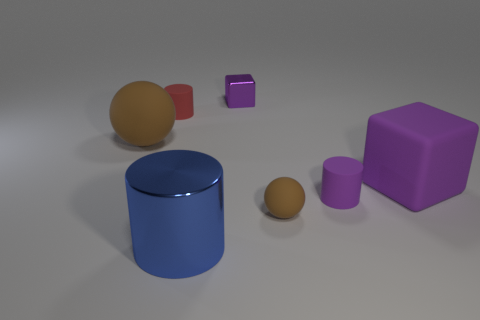There is a brown matte sphere that is left of the shiny cube; is its size the same as the purple object behind the tiny red rubber thing?
Offer a terse response. No. What number of balls are either tiny brown matte objects or big purple matte things?
Keep it short and to the point. 1. Are any tiny yellow shiny balls visible?
Provide a succinct answer. No. Does the large ball have the same color as the small ball?
Make the answer very short. Yes. How many objects are either cylinders that are on the left side of the tiny metallic object or large blue metal cylinders?
Offer a very short reply. 2. There is a tiny purple thing that is behind the purple cylinder that is on the right side of the big blue shiny object; what number of purple matte things are to the right of it?
Provide a short and direct response. 2. There is a thing behind the matte thing behind the large brown rubber object behind the purple cylinder; what is its shape?
Your answer should be very brief. Cube. How many other things are there of the same color as the tiny metallic cube?
Give a very brief answer. 2. The object that is behind the rubber cylinder on the left side of the small brown thing is what shape?
Offer a terse response. Cube. What number of purple matte cylinders are in front of the small cube?
Your answer should be compact. 1. 